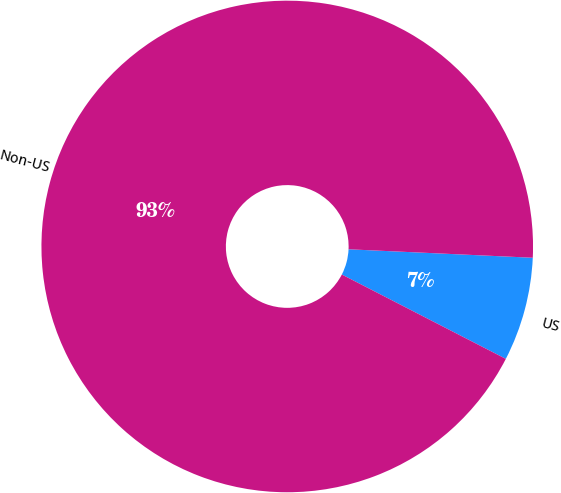Convert chart to OTSL. <chart><loc_0><loc_0><loc_500><loc_500><pie_chart><fcel>US<fcel>Non-US<nl><fcel>6.83%<fcel>93.17%<nl></chart> 